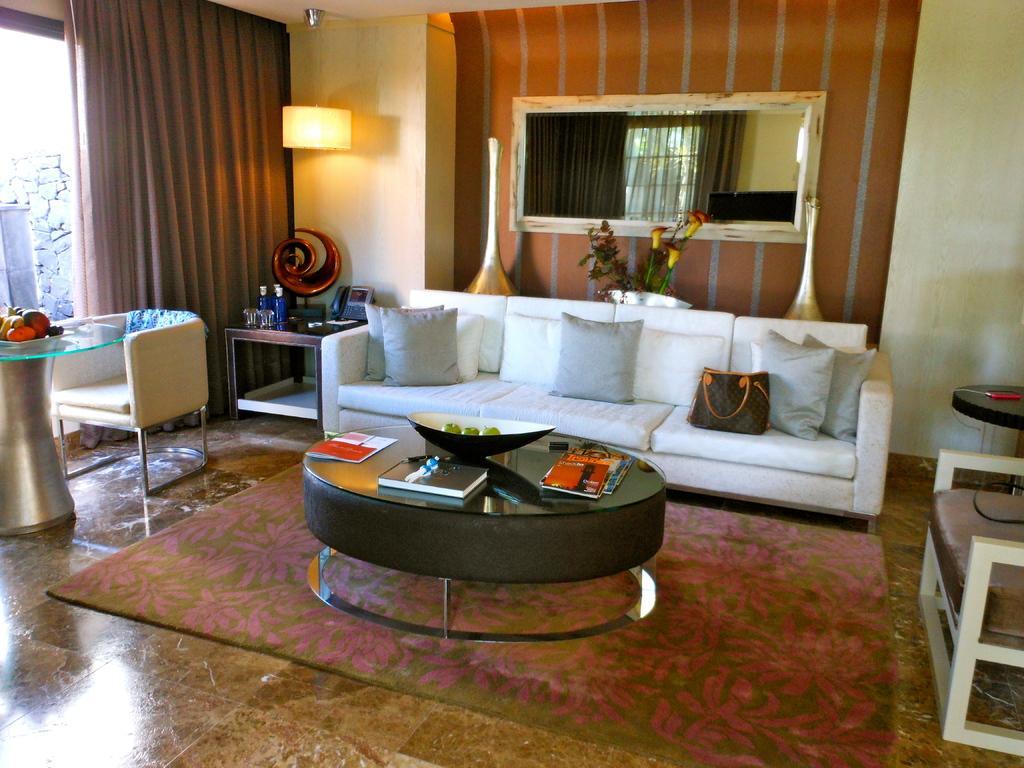In one or two sentences, can you explain what this image depicts? In the picture we can see a house, inside the house we can see a sofa with pillows, a table, on the table we can find the books, a bowl, and apples, beside that there is a chair and a glass window and curtain, light, near the light there is another table, we can find a phone on it and a floor mat. 